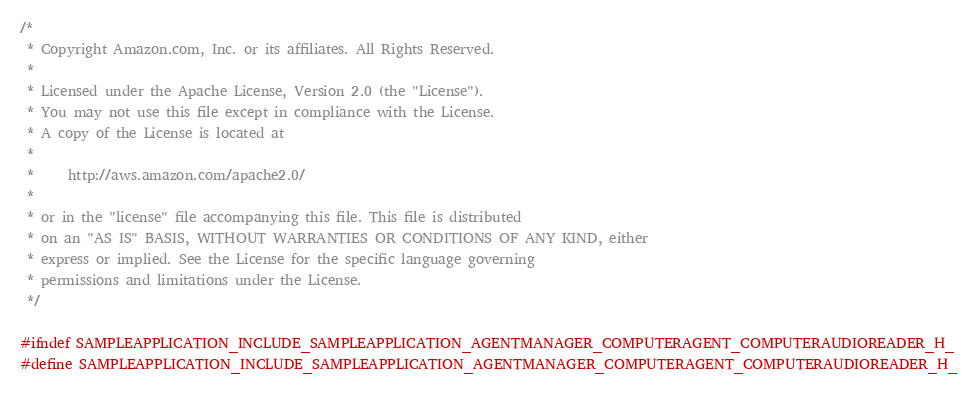<code> <loc_0><loc_0><loc_500><loc_500><_C_>/*
 * Copyright Amazon.com, Inc. or its affiliates. All Rights Reserved.
 *
 * Licensed under the Apache License, Version 2.0 (the "License").
 * You may not use this file except in compliance with the License.
 * A copy of the License is located at
 *
 *     http://aws.amazon.com/apache2.0/
 *
 * or in the "license" file accompanying this file. This file is distributed
 * on an "AS IS" BASIS, WITHOUT WARRANTIES OR CONDITIONS OF ANY KIND, either
 * express or implied. See the License for the specific language governing
 * permissions and limitations under the License.
 */

#ifndef SAMPLEAPPLICATION_INCLUDE_SAMPLEAPPLICATION_AGENTMANAGER_COMPUTERAGENT_COMPUTERAUDIOREADER_H_
#define SAMPLEAPPLICATION_INCLUDE_SAMPLEAPPLICATION_AGENTMANAGER_COMPUTERAGENT_COMPUTERAUDIOREADER_H_
</code> 